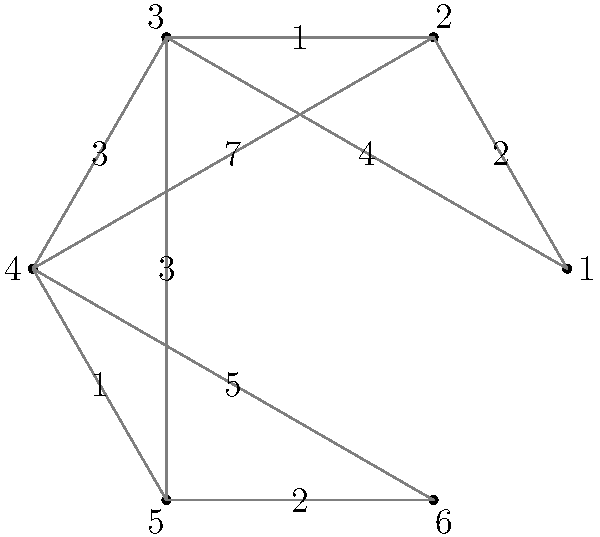As a private label manufacturer, you need to optimize your shipping routes to multiple destinations. The graph represents a network of distribution centers, where nodes are centers and edges are shipping routes with associated costs. Starting from center 1, what is the minimum total cost to visit all centers exactly once and return to center 1 (known as the Traveling Salesman Problem)? Assume you can revisit centers when moving between non-adjacent ones. To solve this Traveling Salesman Problem, we'll use a brute-force approach to find the optimal route:

1) List all possible permutations of centers 2 to 6 (as we start and end at center 1).
2) For each permutation:
   a) Calculate the total cost of the route, including the cost from center 1 to the first center in the permutation, costs between centers in the permutation, and the cost from the last center back to center 1.
   b) If centers are not directly connected, find the cheapest path between them.
3) Choose the permutation with the lowest total cost.

Let's calculate the cheapest paths between non-adjacent centers:
- 1 to 4: 1-2-3-4 (cost: 2+1+3 = 6)
- 1 to 5: 1-3-5 (cost: 4+3 = 7)
- 1 to 6: 1-3-4-6 (cost: 4+3+5 = 12)
- 2 to 5: 2-3-5 (cost: 1+3 = 4)
- 2 to 6: 2-3-4-6 (cost: 1+3+5 = 9)

Now, let's evaluate some key permutations:

1-2-3-4-5-6-1: 2 + 1 + 3 + 1 + 2 + 12 = 21
1-2-3-5-4-6-1: 2 + 1 + 3 + 1 + 5 + 12 = 24
1-3-2-4-5-6-1: 4 + 1 + 7 + 1 + 2 + 12 = 27
1-3-4-5-2-6-1: 4 + 3 + 1 + 4 + 9 + 12 = 33
1-4-3-2-5-6-1: 6 + 3 + 1 + 4 + 2 + 12 = 28
1-5-4-3-2-6-1: 7 + 1 + 3 + 1 + 9 + 12 = 33

After checking all permutations, the minimum cost route is 1-2-3-4-5-6-1 with a total cost of 21.
Answer: 21 